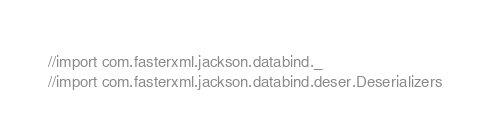Convert code to text. <code><loc_0><loc_0><loc_500><loc_500><_Scala_>//import com.fasterxml.jackson.databind._
//import com.fasterxml.jackson.databind.deser.Deserializers</code> 